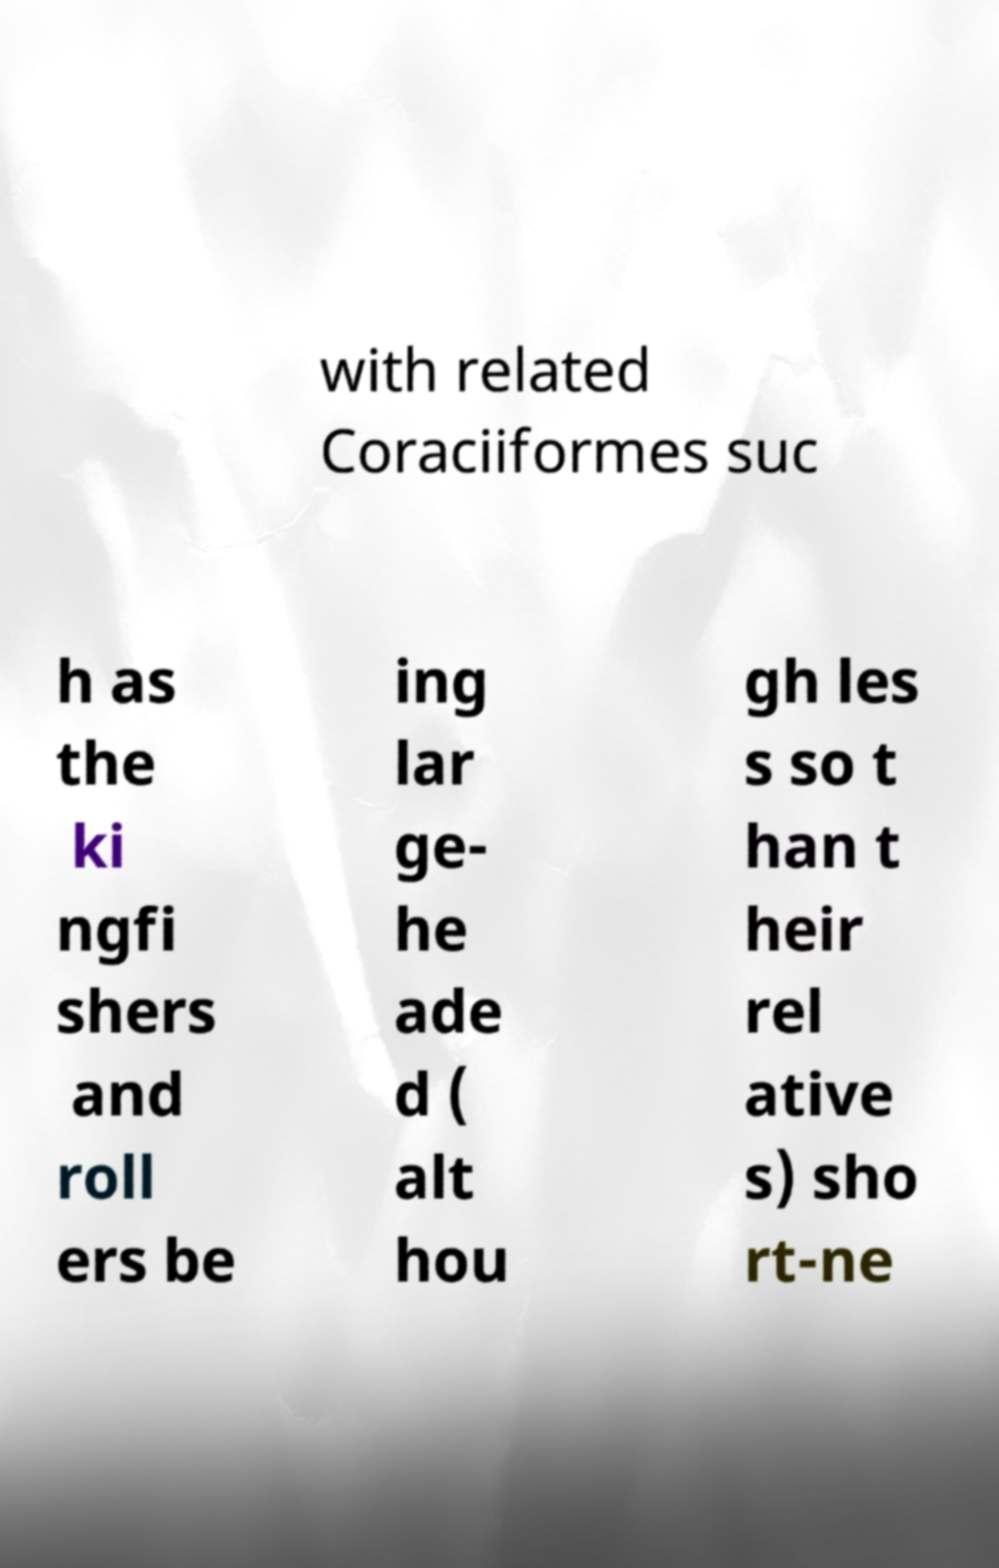Can you read and provide the text displayed in the image?This photo seems to have some interesting text. Can you extract and type it out for me? with related Coraciiformes suc h as the ki ngfi shers and roll ers be ing lar ge- he ade d ( alt hou gh les s so t han t heir rel ative s) sho rt-ne 